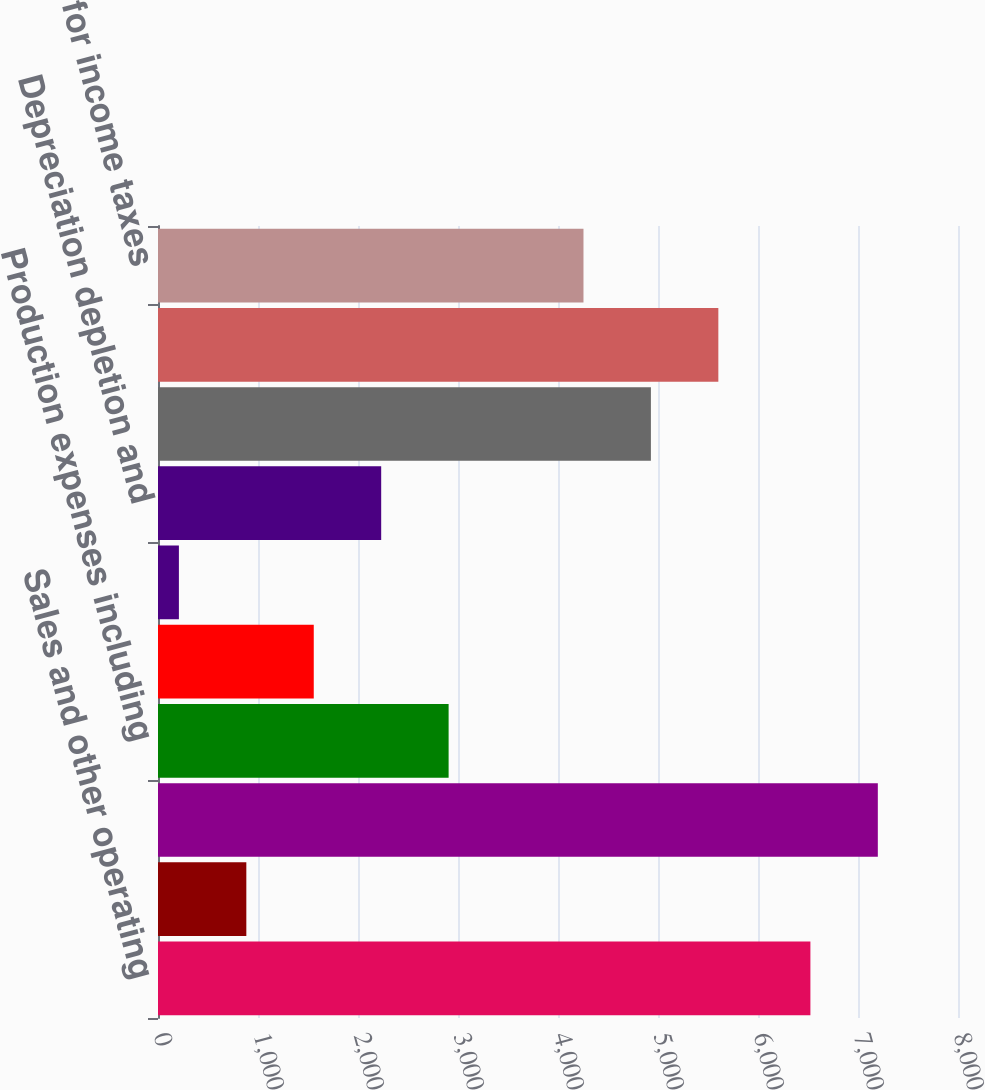Convert chart. <chart><loc_0><loc_0><loc_500><loc_500><bar_chart><fcel>Sales and other operating<fcel>Other net<fcel>Total revenues and non<fcel>Production expenses including<fcel>Exploration expenses including<fcel>General administrative and<fcel>Depreciation depletion and<fcel>Total costs and expenses<fcel>Results of operations from<fcel>Provision for income taxes<nl><fcel>6524<fcel>883.3<fcel>7198.3<fcel>2906.2<fcel>1557.6<fcel>209<fcel>2231.9<fcel>4929.1<fcel>5603.4<fcel>4254.8<nl></chart> 